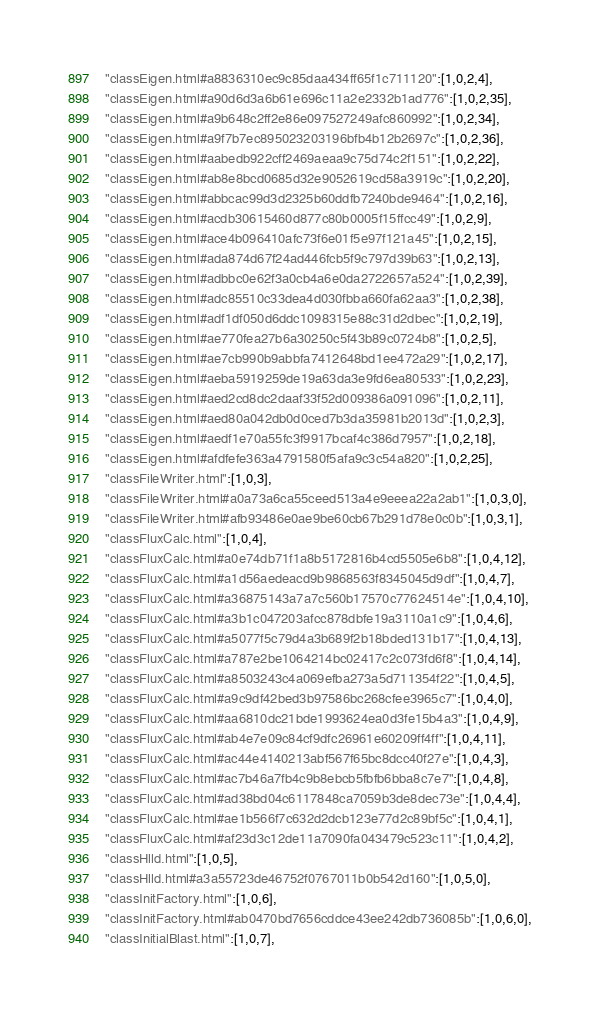Convert code to text. <code><loc_0><loc_0><loc_500><loc_500><_JavaScript_>"classEigen.html#a8836310ec9c85daa434ff65f1c711120":[1,0,2,4],
"classEigen.html#a90d6d3a6b61e696c11a2e2332b1ad776":[1,0,2,35],
"classEigen.html#a9b648c2ff2e86e097527249afc860992":[1,0,2,34],
"classEigen.html#a9f7b7ec895023203196bfb4b12b2697c":[1,0,2,36],
"classEigen.html#aabedb922cff2469aeaa9c75d74c2f151":[1,0,2,22],
"classEigen.html#ab8e8bcd0685d32e9052619cd58a3919c":[1,0,2,20],
"classEigen.html#abbcac99d3d2325b60ddfb7240bde9464":[1,0,2,16],
"classEigen.html#acdb30615460d877c80b0005f15ffcc49":[1,0,2,9],
"classEigen.html#ace4b096410afc73f6e01f5e97f121a45":[1,0,2,15],
"classEigen.html#ada874d67f24ad446fcb5f9c797d39b63":[1,0,2,13],
"classEigen.html#adbbc0e62f3a0cb4a6e0da2722657a524":[1,0,2,39],
"classEigen.html#adc85510c33dea4d030fbba660fa62aa3":[1,0,2,38],
"classEigen.html#adf1df050d6ddc1098315e88c31d2dbec":[1,0,2,19],
"classEigen.html#ae770fea27b6a30250c5f43b89c0724b8":[1,0,2,5],
"classEigen.html#ae7cb990b9abbfa7412648bd1ee472a29":[1,0,2,17],
"classEigen.html#aeba5919259de19a63da3e9fd6ea80533":[1,0,2,23],
"classEigen.html#aed2cd8dc2daaf33f52d009386a091096":[1,0,2,11],
"classEigen.html#aed80a042db0d0ced7b3da35981b2013d":[1,0,2,3],
"classEigen.html#aedf1e70a55fc3f9917bcaf4c386d7957":[1,0,2,18],
"classEigen.html#afdfefe363a4791580f5afa9c3c54a820":[1,0,2,25],
"classFileWriter.html":[1,0,3],
"classFileWriter.html#a0a73a6ca55ceed513a4e9eeea22a2ab1":[1,0,3,0],
"classFileWriter.html#afb93486e0ae9be60cb67b291d78e0c0b":[1,0,3,1],
"classFluxCalc.html":[1,0,4],
"classFluxCalc.html#a0e74db71f1a8b5172816b4cd5505e6b8":[1,0,4,12],
"classFluxCalc.html#a1d56aedeacd9b9868563f8345045d9df":[1,0,4,7],
"classFluxCalc.html#a36875143a7a7c560b17570c77624514e":[1,0,4,10],
"classFluxCalc.html#a3b1c047203afcc878dbfe19a3110a1c9":[1,0,4,6],
"classFluxCalc.html#a5077f5c79d4a3b689f2b18bded131b17":[1,0,4,13],
"classFluxCalc.html#a787e2be1064214bc02417c2c073fd6f8":[1,0,4,14],
"classFluxCalc.html#a8503243c4a069efba273a5d711354f22":[1,0,4,5],
"classFluxCalc.html#a9c9df42bed3b97586bc268cfee3965c7":[1,0,4,0],
"classFluxCalc.html#aa6810dc21bde1993624ea0d3fe15b4a3":[1,0,4,9],
"classFluxCalc.html#ab4e7e09c84cf9dfc26961e60209ff4ff":[1,0,4,11],
"classFluxCalc.html#ac44e4140213abf567f65bc8dcc40f27e":[1,0,4,3],
"classFluxCalc.html#ac7b46a7fb4c9b8ebcb5fbfb6bba8c7e7":[1,0,4,8],
"classFluxCalc.html#ad38bd04c6117848ca7059b3de8dec73e":[1,0,4,4],
"classFluxCalc.html#ae1b566f7c632d2dcb123e77d2c89bf5c":[1,0,4,1],
"classFluxCalc.html#af23d3c12de11a7090fa043479c523c11":[1,0,4,2],
"classHlld.html":[1,0,5],
"classHlld.html#a3a55723de46752f0767011b0b542d160":[1,0,5,0],
"classInitFactory.html":[1,0,6],
"classInitFactory.html#ab0470bd7656cddce43ee242db736085b":[1,0,6,0],
"classInitialBlast.html":[1,0,7],</code> 